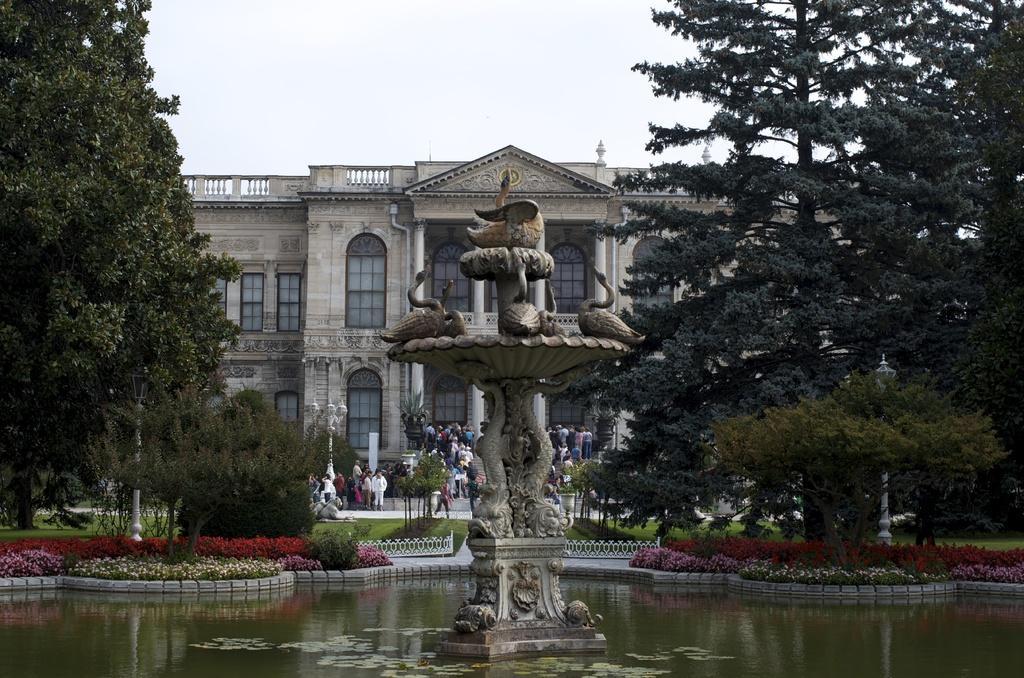How would you summarize this image in a sentence or two? In this picture we can see a fountain, water and in the background we can see a building, people, trees, sky. 